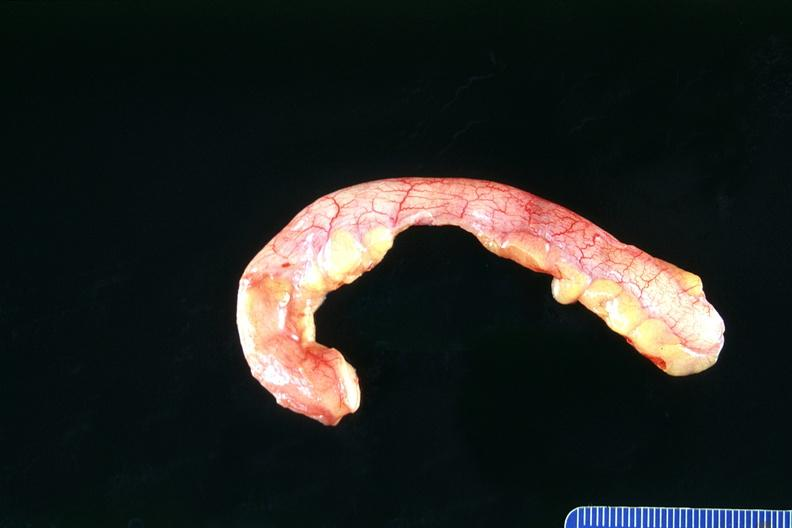what is present?
Answer the question using a single word or phrase. Gastrointestinal 